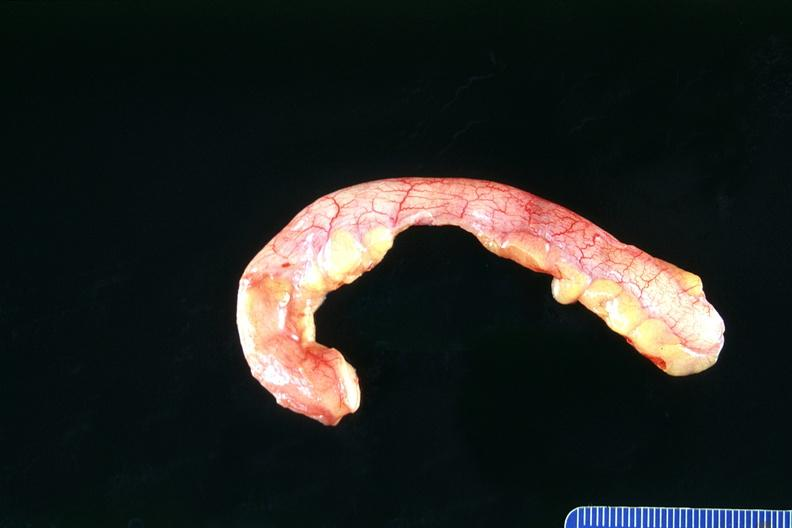what is present?
Answer the question using a single word or phrase. Gastrointestinal 